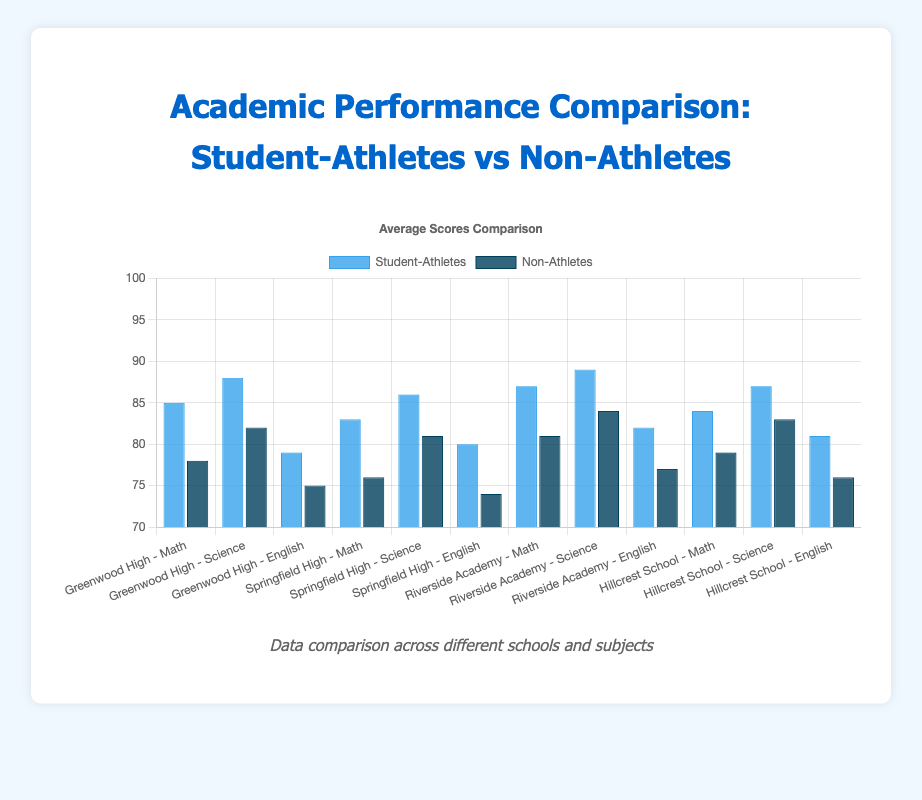What's the difference in average Mathematics score between student-athletes and non-athletes at Greenwood High? The average Mathematics score for student-athletes at Greenwood High is 85, and for non-athletes, it is 78. Therefore, the difference is 85 - 78 = 7.
Answer: 7 Which school has the smallest difference in Science scores between student-athletes and non-athletes? By examining the Science scores, the differences are: Greenwood High (88-82=6), Springfield High (86-81=5), Riverside Academy (89-84=5), Hillcrest School (87-83=4). The smallest difference is at Hillcrest School with a difference of 4.
Answer: Hillcrest School Among the student-athletes, which academic subject has the highest average score and what is it? Reviewing the bar heights for student-athletes across all subjects, the highest average score is in Science at Riverside Academy with a score of 89.
Answer: Science at Riverside Academy, 89 How does the overall performance of non-athlete students in English compare across all schools? The non-athlete English scores for each school are: Greenwood High (75), Springfield High (74), Riverside Academy (77), Hillcrest School (76). Among them, Riverside Academy has the highest score (77) and Springfield High has the lowest (74).
Answer: Springfield High has the lowest; Riverside Academy has the highest What is the total average score difference between student-athletes and non-athletes across all subjects at Springfield High? The differences for Springfield High are Mathematics (83-76=7), Science (86-81=5), English (80-74=6). Summing these up: 7+5+6=18, total average score difference is 18.
Answer: 18 In which subject do non-athletes at Riverside Academy perform closest in score to their student-athlete peers? At Riverside Academy, the differences in scores are Mathematics (87-81=6), Science (89-84=5), English (82-77=5). Science and English both have the smallest difference of 5 points.
Answer: Science and English Explain the trend in average Science scores for student-athletes across the different schools. The average Science scores for student-athletes are: Greenwood High (88), Springfield High (86), Riverside Academy (89), Hillcrest School (87). These scores are quite close, ranging from 86 to 89, indicating consistently high performance in Science among student-athletes across all schools.
Answer: Consistently high (86-89) Which school’s student-athletes have the highest average overall performance across all academic subjects? To find the highest overall performance, calculate the sum of scores for each school's student-athletes and compare: Greenwood High (85+88+79=252), Springfield High (83+86+80=249), Riverside Academy (87+89+82=258), Hillcrest School (84+87+81=252). Riverside Academy has the highest total of 258.
Answer: Riverside Academy What is the visual difference between the bars representing student-athletes and non-athletes in Mathematics at Hillcrest School? The bar for student-athletes in Mathematics at Hillcrest School is higher and colored in a lighter blue compared to the lower, darker blue bar for non-athletes. This indicates student-athletes have a higher score.
Answer: Higher and lighter blue (student-athletes), lower and darker blue (non-athletes) 